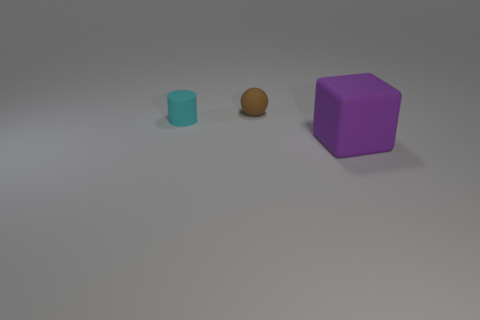Add 1 big green rubber spheres. How many objects exist? 4 Subtract all cubes. How many objects are left? 2 Subtract 0 red spheres. How many objects are left? 3 Subtract all tiny brown blocks. Subtract all small matte things. How many objects are left? 1 Add 1 tiny rubber cylinders. How many tiny rubber cylinders are left? 2 Add 2 large objects. How many large objects exist? 3 